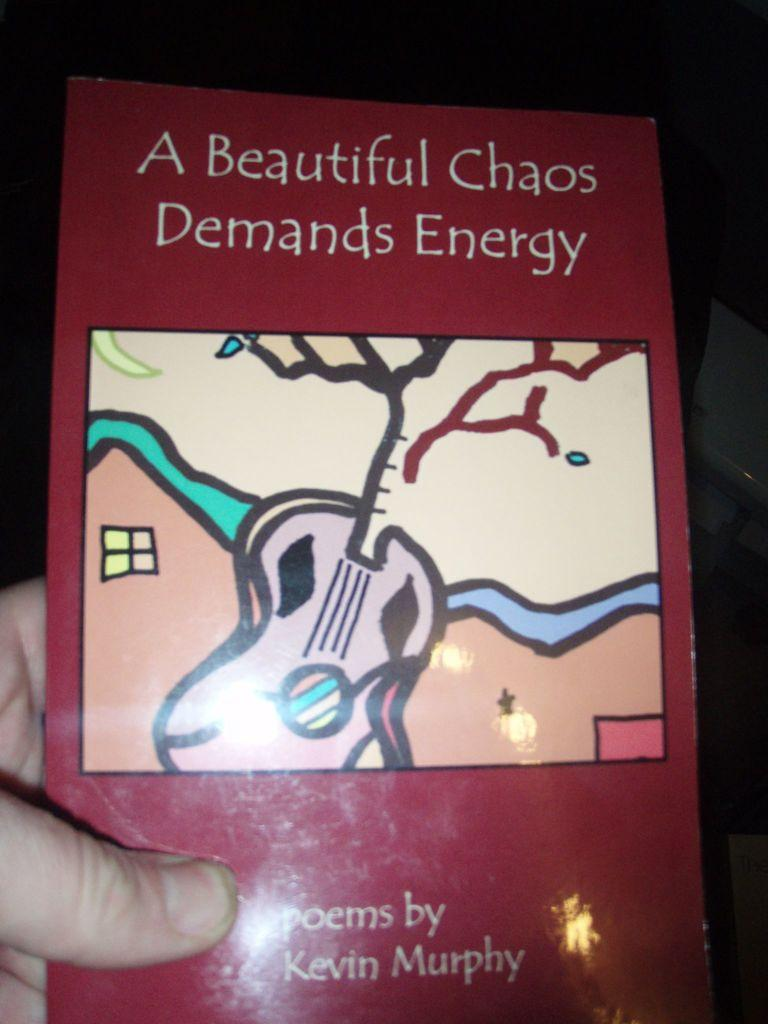<image>
Share a concise interpretation of the image provided. A book of poems called: A beautiful Chaos Demands Energy. 